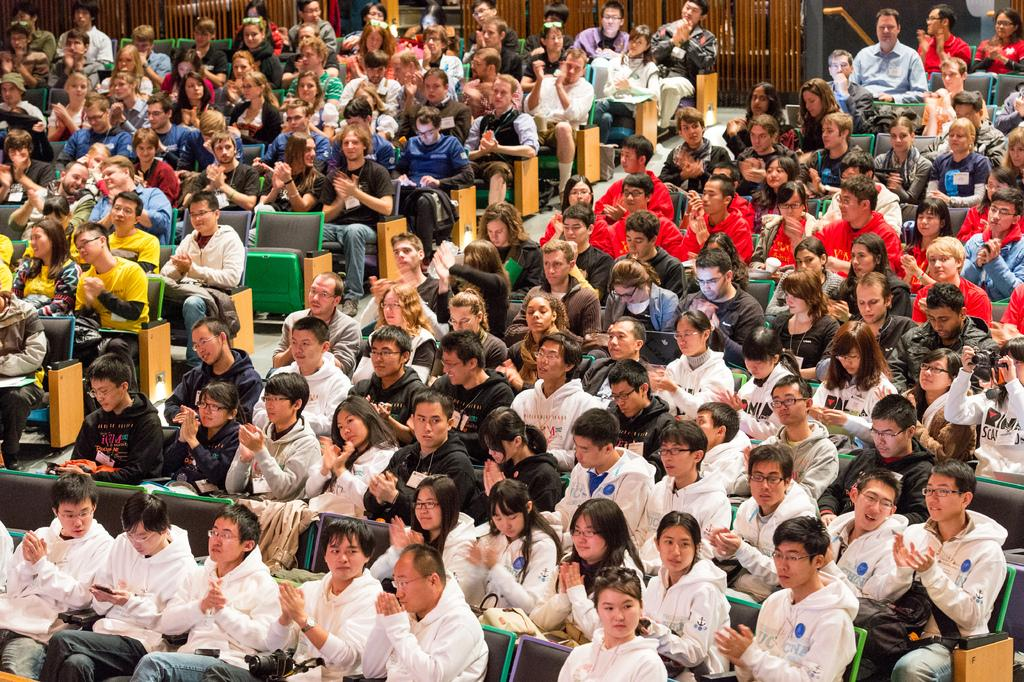What are the people in the image doing? The people in the image are sitting on chairs. What can be seen in the background of the image? There are metal grills in the background of the image. What shape is the credit card that the person is holding in the image? There is no credit card or person holding a credit card visible in the image. 